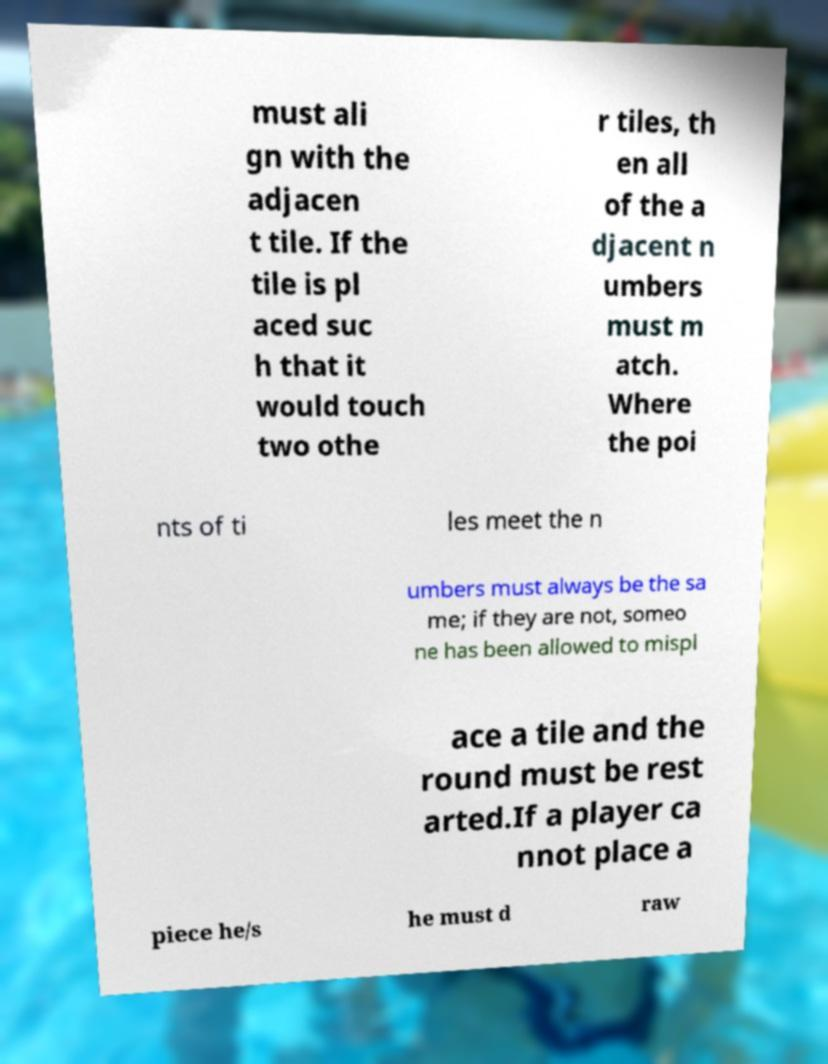Could you assist in decoding the text presented in this image and type it out clearly? must ali gn with the adjacen t tile. If the tile is pl aced suc h that it would touch two othe r tiles, th en all of the a djacent n umbers must m atch. Where the poi nts of ti les meet the n umbers must always be the sa me; if they are not, someo ne has been allowed to mispl ace a tile and the round must be rest arted.If a player ca nnot place a piece he/s he must d raw 